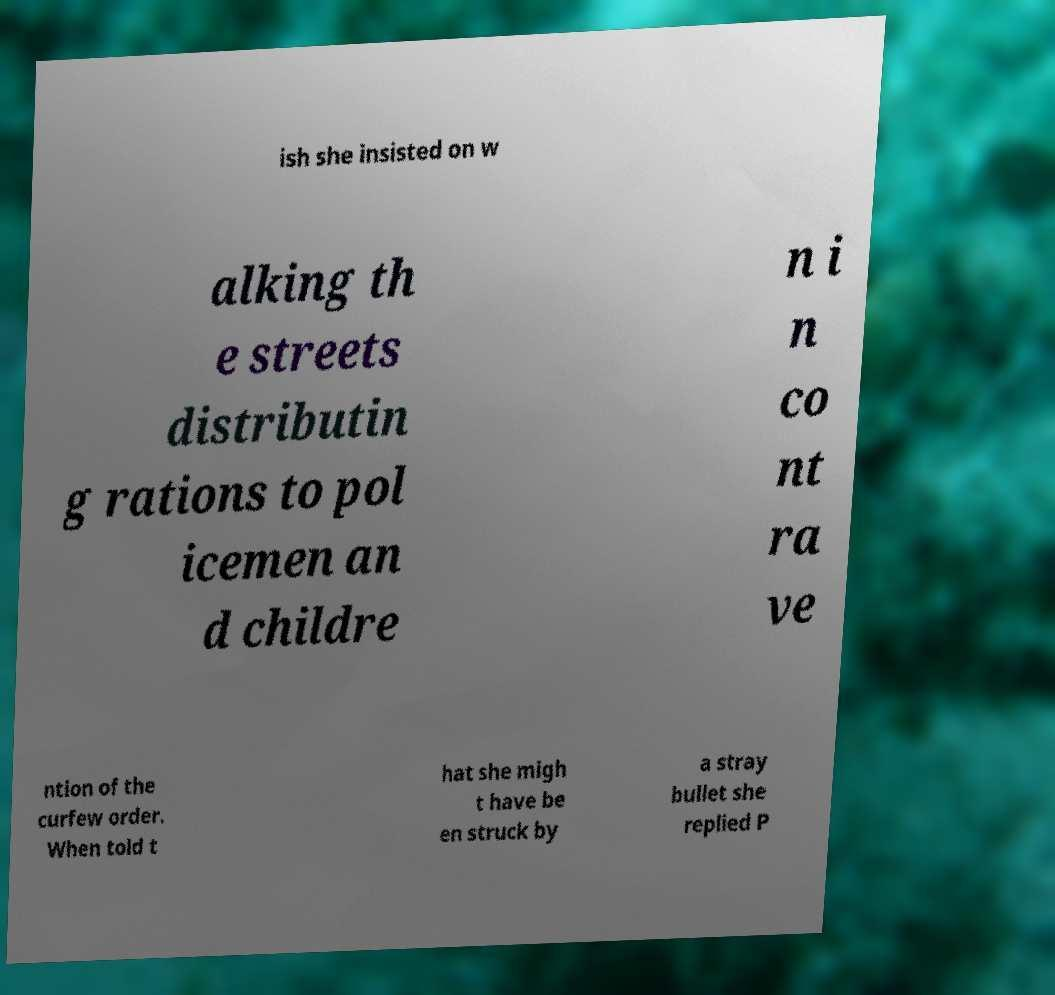For documentation purposes, I need the text within this image transcribed. Could you provide that? ish she insisted on w alking th e streets distributin g rations to pol icemen an d childre n i n co nt ra ve ntion of the curfew order. When told t hat she migh t have be en struck by a stray bullet she replied P 